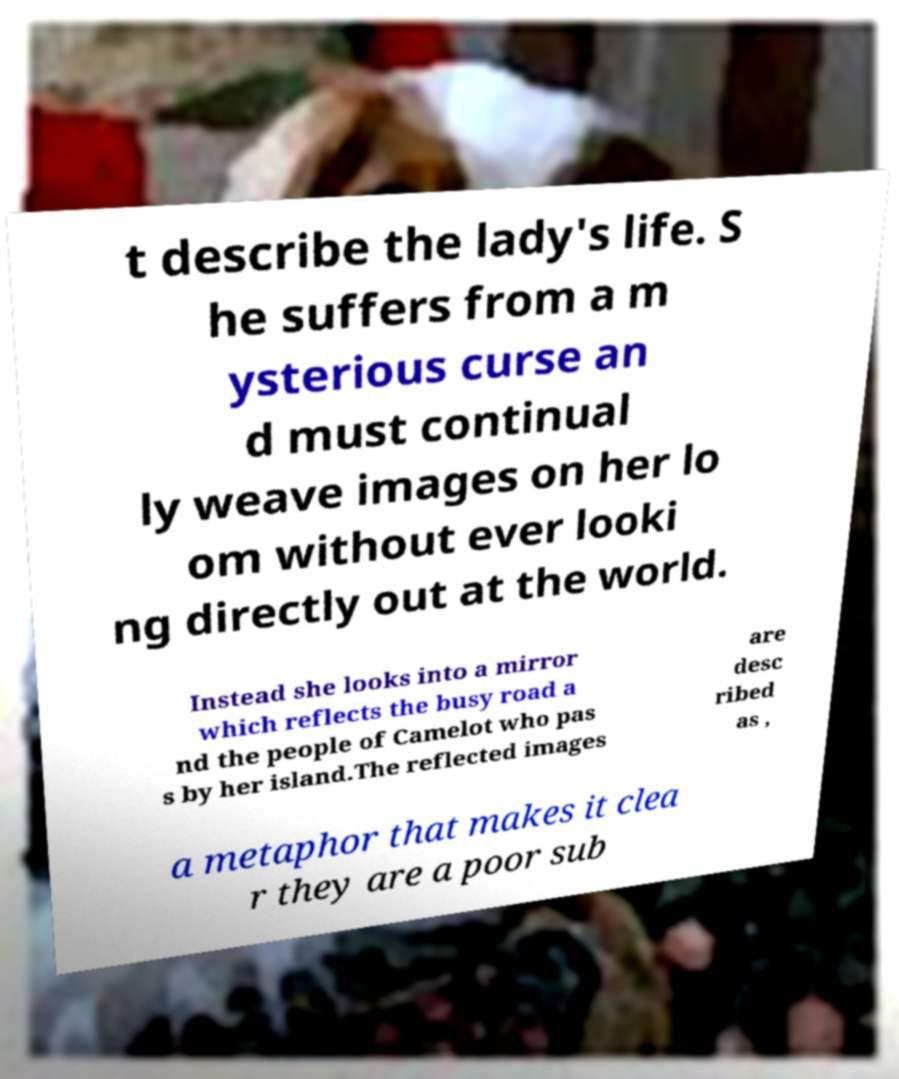Please read and relay the text visible in this image. What does it say? t describe the lady's life. S he suffers from a m ysterious curse an d must continual ly weave images on her lo om without ever looki ng directly out at the world. Instead she looks into a mirror which reflects the busy road a nd the people of Camelot who pas s by her island.The reflected images are desc ribed as , a metaphor that makes it clea r they are a poor sub 